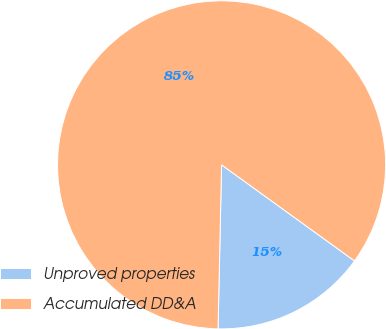Convert chart. <chart><loc_0><loc_0><loc_500><loc_500><pie_chart><fcel>Unproved properties<fcel>Accumulated DD&A<nl><fcel>15.38%<fcel>84.62%<nl></chart> 